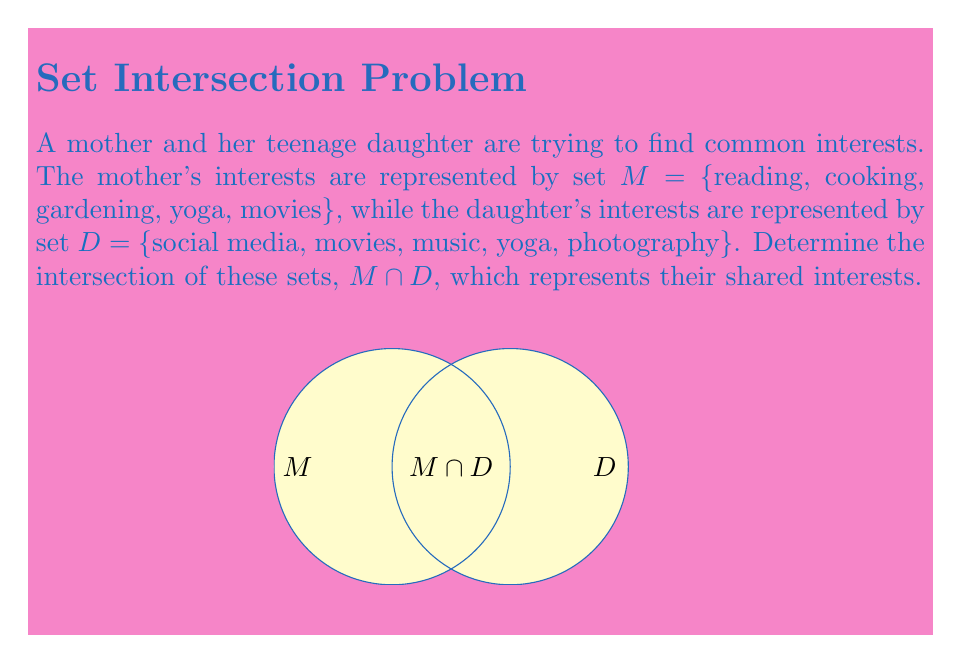Can you solve this math problem? To find the intersection of sets $M$ and $D$, we need to identify the elements that are present in both sets. Let's follow these steps:

1) List out the elements of each set:
   $M = \{reading, cooking, gardening, yoga, movies\}$
   $D = \{social media, movies, music, yoga, photography\}$

2) Compare the elements in both sets and identify those that appear in both:
   - "yoga" is in both $M$ and $D$
   - "movies" is in both $M$ and $D$

3) The intersection $M \cap D$ consists of all elements that are in both sets. Therefore:
   $M \cap D = \{yoga, movies\}$

This result represents the shared interests between the mother and daughter, which could serve as a starting point for bonding and communication.
Answer: $M \cap D = \{yoga, movies\}$ 